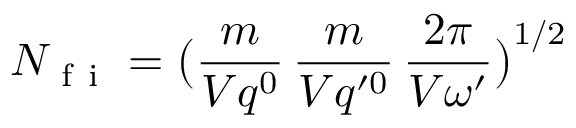Convert formula to latex. <formula><loc_0><loc_0><loc_500><loc_500>N _ { f i } = \left ( \frac { m } { V q ^ { 0 } } \, \frac { m } { V q ^ { \prime 0 } } \, \frac { 2 \pi } { V \omega ^ { \prime } } \right ) ^ { 1 / 2 }</formula> 